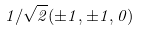Convert formula to latex. <formula><loc_0><loc_0><loc_500><loc_500>1 / \sqrt { 2 } ( \pm 1 , \pm 1 , 0 )</formula> 